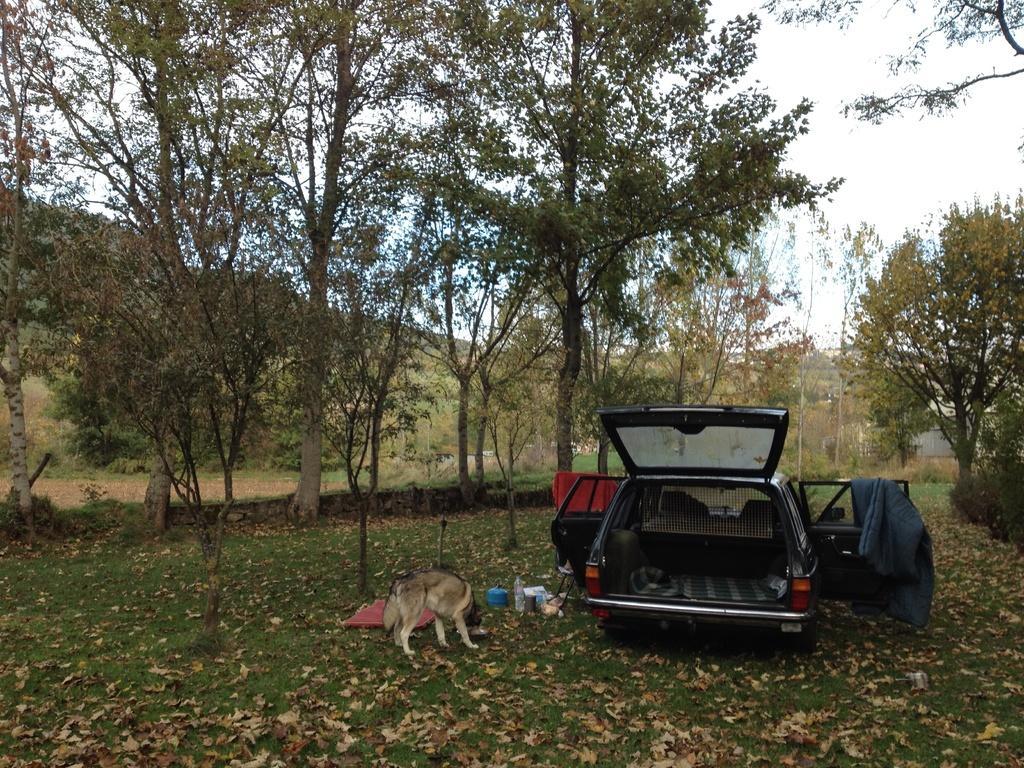How would you summarize this image in a sentence or two? In this image we can see a car. There are many objects placed on the ground. There is a dog in the image. There is a grassy land in the image. There is a sky in the image. There is a house at the right side of the image. There are many dry leaves on the ground. There are few objects attached to a car. 